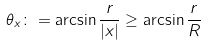<formula> <loc_0><loc_0><loc_500><loc_500>\theta _ { x } \colon = \arcsin \frac { r } { | x | } \geq \arcsin \frac { r } { R }</formula> 